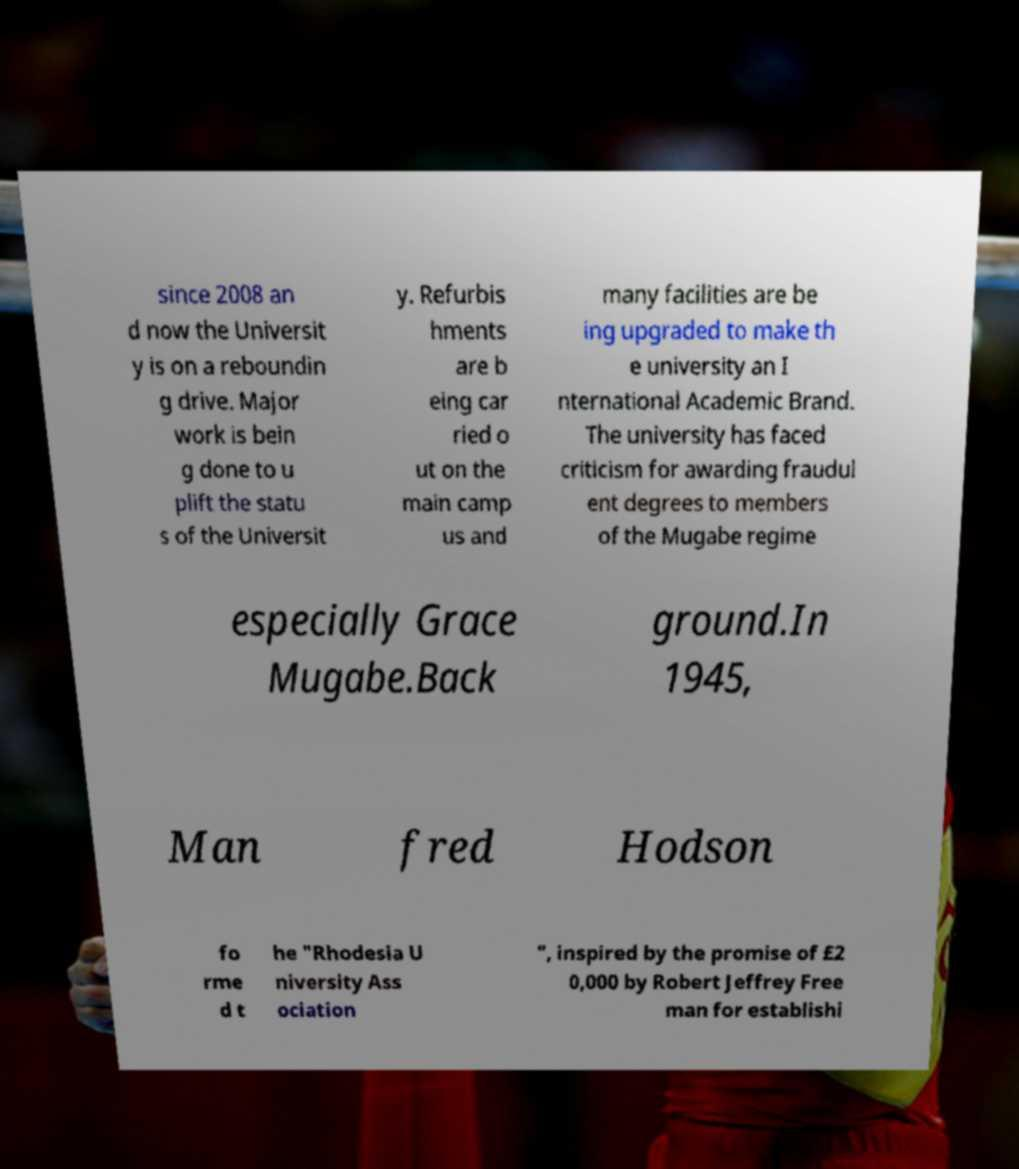Please read and relay the text visible in this image. What does it say? since 2008 an d now the Universit y is on a reboundin g drive. Major work is bein g done to u plift the statu s of the Universit y. Refurbis hments are b eing car ried o ut on the main camp us and many facilities are be ing upgraded to make th e university an I nternational Academic Brand. The university has faced criticism for awarding fraudul ent degrees to members of the Mugabe regime especially Grace Mugabe.Back ground.In 1945, Man fred Hodson fo rme d t he "Rhodesia U niversity Ass ociation ", inspired by the promise of £2 0,000 by Robert Jeffrey Free man for establishi 